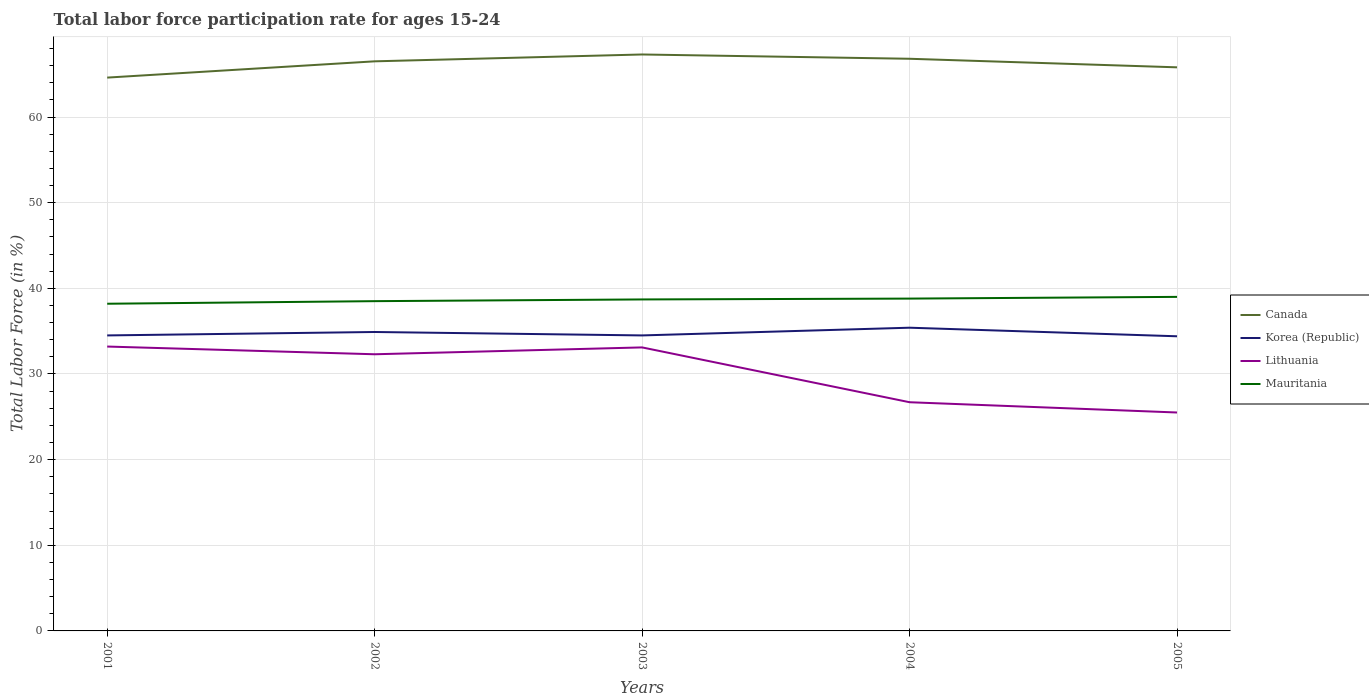How many different coloured lines are there?
Provide a short and direct response. 4. Does the line corresponding to Canada intersect with the line corresponding to Mauritania?
Make the answer very short. No. Across all years, what is the maximum labor force participation rate in Mauritania?
Keep it short and to the point. 38.2. What is the difference between the highest and the second highest labor force participation rate in Mauritania?
Provide a short and direct response. 0.8. Is the labor force participation rate in Lithuania strictly greater than the labor force participation rate in Korea (Republic) over the years?
Your answer should be compact. Yes. What is the difference between two consecutive major ticks on the Y-axis?
Provide a succinct answer. 10. Does the graph contain any zero values?
Give a very brief answer. No. Does the graph contain grids?
Your response must be concise. Yes. Where does the legend appear in the graph?
Provide a short and direct response. Center right. How many legend labels are there?
Your answer should be very brief. 4. What is the title of the graph?
Offer a very short reply. Total labor force participation rate for ages 15-24. Does "Timor-Leste" appear as one of the legend labels in the graph?
Provide a short and direct response. No. What is the Total Labor Force (in %) in Canada in 2001?
Your answer should be very brief. 64.6. What is the Total Labor Force (in %) in Korea (Republic) in 2001?
Make the answer very short. 34.5. What is the Total Labor Force (in %) of Lithuania in 2001?
Offer a terse response. 33.2. What is the Total Labor Force (in %) in Mauritania in 2001?
Ensure brevity in your answer.  38.2. What is the Total Labor Force (in %) of Canada in 2002?
Make the answer very short. 66.5. What is the Total Labor Force (in %) of Korea (Republic) in 2002?
Offer a very short reply. 34.9. What is the Total Labor Force (in %) of Lithuania in 2002?
Offer a very short reply. 32.3. What is the Total Labor Force (in %) of Mauritania in 2002?
Your answer should be compact. 38.5. What is the Total Labor Force (in %) in Canada in 2003?
Your response must be concise. 67.3. What is the Total Labor Force (in %) in Korea (Republic) in 2003?
Offer a terse response. 34.5. What is the Total Labor Force (in %) of Lithuania in 2003?
Your response must be concise. 33.1. What is the Total Labor Force (in %) in Mauritania in 2003?
Your answer should be very brief. 38.7. What is the Total Labor Force (in %) of Canada in 2004?
Your answer should be very brief. 66.8. What is the Total Labor Force (in %) of Korea (Republic) in 2004?
Offer a very short reply. 35.4. What is the Total Labor Force (in %) in Lithuania in 2004?
Offer a very short reply. 26.7. What is the Total Labor Force (in %) of Mauritania in 2004?
Give a very brief answer. 38.8. What is the Total Labor Force (in %) of Canada in 2005?
Provide a short and direct response. 65.8. What is the Total Labor Force (in %) of Korea (Republic) in 2005?
Offer a very short reply. 34.4. Across all years, what is the maximum Total Labor Force (in %) in Canada?
Make the answer very short. 67.3. Across all years, what is the maximum Total Labor Force (in %) of Korea (Republic)?
Give a very brief answer. 35.4. Across all years, what is the maximum Total Labor Force (in %) of Lithuania?
Your answer should be compact. 33.2. Across all years, what is the minimum Total Labor Force (in %) of Canada?
Make the answer very short. 64.6. Across all years, what is the minimum Total Labor Force (in %) of Korea (Republic)?
Your response must be concise. 34.4. Across all years, what is the minimum Total Labor Force (in %) of Lithuania?
Your response must be concise. 25.5. Across all years, what is the minimum Total Labor Force (in %) of Mauritania?
Your answer should be very brief. 38.2. What is the total Total Labor Force (in %) in Canada in the graph?
Give a very brief answer. 331. What is the total Total Labor Force (in %) in Korea (Republic) in the graph?
Give a very brief answer. 173.7. What is the total Total Labor Force (in %) in Lithuania in the graph?
Your response must be concise. 150.8. What is the total Total Labor Force (in %) of Mauritania in the graph?
Your answer should be very brief. 193.2. What is the difference between the Total Labor Force (in %) of Lithuania in 2001 and that in 2003?
Your response must be concise. 0.1. What is the difference between the Total Labor Force (in %) of Mauritania in 2001 and that in 2003?
Offer a terse response. -0.5. What is the difference between the Total Labor Force (in %) of Lithuania in 2001 and that in 2004?
Offer a very short reply. 6.5. What is the difference between the Total Labor Force (in %) of Canada in 2001 and that in 2005?
Give a very brief answer. -1.2. What is the difference between the Total Labor Force (in %) of Korea (Republic) in 2001 and that in 2005?
Provide a short and direct response. 0.1. What is the difference between the Total Labor Force (in %) of Lithuania in 2001 and that in 2005?
Your answer should be compact. 7.7. What is the difference between the Total Labor Force (in %) in Korea (Republic) in 2002 and that in 2003?
Give a very brief answer. 0.4. What is the difference between the Total Labor Force (in %) of Canada in 2002 and that in 2004?
Make the answer very short. -0.3. What is the difference between the Total Labor Force (in %) of Lithuania in 2002 and that in 2004?
Your answer should be compact. 5.6. What is the difference between the Total Labor Force (in %) in Mauritania in 2002 and that in 2004?
Provide a succinct answer. -0.3. What is the difference between the Total Labor Force (in %) in Mauritania in 2002 and that in 2005?
Offer a very short reply. -0.5. What is the difference between the Total Labor Force (in %) in Canada in 2003 and that in 2004?
Provide a short and direct response. 0.5. What is the difference between the Total Labor Force (in %) in Lithuania in 2003 and that in 2004?
Keep it short and to the point. 6.4. What is the difference between the Total Labor Force (in %) of Mauritania in 2003 and that in 2004?
Give a very brief answer. -0.1. What is the difference between the Total Labor Force (in %) of Canada in 2003 and that in 2005?
Keep it short and to the point. 1.5. What is the difference between the Total Labor Force (in %) in Korea (Republic) in 2003 and that in 2005?
Offer a terse response. 0.1. What is the difference between the Total Labor Force (in %) of Lithuania in 2003 and that in 2005?
Offer a very short reply. 7.6. What is the difference between the Total Labor Force (in %) of Mauritania in 2003 and that in 2005?
Offer a very short reply. -0.3. What is the difference between the Total Labor Force (in %) of Canada in 2004 and that in 2005?
Your response must be concise. 1. What is the difference between the Total Labor Force (in %) of Canada in 2001 and the Total Labor Force (in %) of Korea (Republic) in 2002?
Make the answer very short. 29.7. What is the difference between the Total Labor Force (in %) of Canada in 2001 and the Total Labor Force (in %) of Lithuania in 2002?
Your answer should be compact. 32.3. What is the difference between the Total Labor Force (in %) in Canada in 2001 and the Total Labor Force (in %) in Mauritania in 2002?
Offer a terse response. 26.1. What is the difference between the Total Labor Force (in %) in Korea (Republic) in 2001 and the Total Labor Force (in %) in Lithuania in 2002?
Offer a very short reply. 2.2. What is the difference between the Total Labor Force (in %) in Korea (Republic) in 2001 and the Total Labor Force (in %) in Mauritania in 2002?
Your answer should be very brief. -4. What is the difference between the Total Labor Force (in %) of Lithuania in 2001 and the Total Labor Force (in %) of Mauritania in 2002?
Provide a short and direct response. -5.3. What is the difference between the Total Labor Force (in %) in Canada in 2001 and the Total Labor Force (in %) in Korea (Republic) in 2003?
Offer a terse response. 30.1. What is the difference between the Total Labor Force (in %) in Canada in 2001 and the Total Labor Force (in %) in Lithuania in 2003?
Your answer should be compact. 31.5. What is the difference between the Total Labor Force (in %) in Canada in 2001 and the Total Labor Force (in %) in Mauritania in 2003?
Provide a succinct answer. 25.9. What is the difference between the Total Labor Force (in %) of Canada in 2001 and the Total Labor Force (in %) of Korea (Republic) in 2004?
Your answer should be compact. 29.2. What is the difference between the Total Labor Force (in %) of Canada in 2001 and the Total Labor Force (in %) of Lithuania in 2004?
Your answer should be very brief. 37.9. What is the difference between the Total Labor Force (in %) of Canada in 2001 and the Total Labor Force (in %) of Mauritania in 2004?
Offer a terse response. 25.8. What is the difference between the Total Labor Force (in %) in Korea (Republic) in 2001 and the Total Labor Force (in %) in Lithuania in 2004?
Your answer should be very brief. 7.8. What is the difference between the Total Labor Force (in %) of Lithuania in 2001 and the Total Labor Force (in %) of Mauritania in 2004?
Offer a very short reply. -5.6. What is the difference between the Total Labor Force (in %) of Canada in 2001 and the Total Labor Force (in %) of Korea (Republic) in 2005?
Ensure brevity in your answer.  30.2. What is the difference between the Total Labor Force (in %) of Canada in 2001 and the Total Labor Force (in %) of Lithuania in 2005?
Keep it short and to the point. 39.1. What is the difference between the Total Labor Force (in %) of Canada in 2001 and the Total Labor Force (in %) of Mauritania in 2005?
Your response must be concise. 25.6. What is the difference between the Total Labor Force (in %) of Korea (Republic) in 2001 and the Total Labor Force (in %) of Lithuania in 2005?
Make the answer very short. 9. What is the difference between the Total Labor Force (in %) in Korea (Republic) in 2001 and the Total Labor Force (in %) in Mauritania in 2005?
Keep it short and to the point. -4.5. What is the difference between the Total Labor Force (in %) in Canada in 2002 and the Total Labor Force (in %) in Korea (Republic) in 2003?
Keep it short and to the point. 32. What is the difference between the Total Labor Force (in %) of Canada in 2002 and the Total Labor Force (in %) of Lithuania in 2003?
Make the answer very short. 33.4. What is the difference between the Total Labor Force (in %) in Canada in 2002 and the Total Labor Force (in %) in Mauritania in 2003?
Make the answer very short. 27.8. What is the difference between the Total Labor Force (in %) in Korea (Republic) in 2002 and the Total Labor Force (in %) in Mauritania in 2003?
Ensure brevity in your answer.  -3.8. What is the difference between the Total Labor Force (in %) in Canada in 2002 and the Total Labor Force (in %) in Korea (Republic) in 2004?
Your answer should be compact. 31.1. What is the difference between the Total Labor Force (in %) of Canada in 2002 and the Total Labor Force (in %) of Lithuania in 2004?
Make the answer very short. 39.8. What is the difference between the Total Labor Force (in %) in Canada in 2002 and the Total Labor Force (in %) in Mauritania in 2004?
Your response must be concise. 27.7. What is the difference between the Total Labor Force (in %) of Korea (Republic) in 2002 and the Total Labor Force (in %) of Lithuania in 2004?
Provide a short and direct response. 8.2. What is the difference between the Total Labor Force (in %) of Korea (Republic) in 2002 and the Total Labor Force (in %) of Mauritania in 2004?
Provide a short and direct response. -3.9. What is the difference between the Total Labor Force (in %) of Lithuania in 2002 and the Total Labor Force (in %) of Mauritania in 2004?
Ensure brevity in your answer.  -6.5. What is the difference between the Total Labor Force (in %) in Canada in 2002 and the Total Labor Force (in %) in Korea (Republic) in 2005?
Provide a succinct answer. 32.1. What is the difference between the Total Labor Force (in %) of Canada in 2003 and the Total Labor Force (in %) of Korea (Republic) in 2004?
Offer a terse response. 31.9. What is the difference between the Total Labor Force (in %) of Canada in 2003 and the Total Labor Force (in %) of Lithuania in 2004?
Make the answer very short. 40.6. What is the difference between the Total Labor Force (in %) of Korea (Republic) in 2003 and the Total Labor Force (in %) of Lithuania in 2004?
Provide a short and direct response. 7.8. What is the difference between the Total Labor Force (in %) of Lithuania in 2003 and the Total Labor Force (in %) of Mauritania in 2004?
Offer a terse response. -5.7. What is the difference between the Total Labor Force (in %) in Canada in 2003 and the Total Labor Force (in %) in Korea (Republic) in 2005?
Offer a terse response. 32.9. What is the difference between the Total Labor Force (in %) of Canada in 2003 and the Total Labor Force (in %) of Lithuania in 2005?
Ensure brevity in your answer.  41.8. What is the difference between the Total Labor Force (in %) of Canada in 2003 and the Total Labor Force (in %) of Mauritania in 2005?
Your answer should be very brief. 28.3. What is the difference between the Total Labor Force (in %) of Canada in 2004 and the Total Labor Force (in %) of Korea (Republic) in 2005?
Provide a short and direct response. 32.4. What is the difference between the Total Labor Force (in %) in Canada in 2004 and the Total Labor Force (in %) in Lithuania in 2005?
Ensure brevity in your answer.  41.3. What is the difference between the Total Labor Force (in %) of Canada in 2004 and the Total Labor Force (in %) of Mauritania in 2005?
Keep it short and to the point. 27.8. What is the average Total Labor Force (in %) of Canada per year?
Your answer should be very brief. 66.2. What is the average Total Labor Force (in %) in Korea (Republic) per year?
Ensure brevity in your answer.  34.74. What is the average Total Labor Force (in %) in Lithuania per year?
Provide a succinct answer. 30.16. What is the average Total Labor Force (in %) of Mauritania per year?
Provide a short and direct response. 38.64. In the year 2001, what is the difference between the Total Labor Force (in %) in Canada and Total Labor Force (in %) in Korea (Republic)?
Your response must be concise. 30.1. In the year 2001, what is the difference between the Total Labor Force (in %) of Canada and Total Labor Force (in %) of Lithuania?
Offer a very short reply. 31.4. In the year 2001, what is the difference between the Total Labor Force (in %) in Canada and Total Labor Force (in %) in Mauritania?
Offer a very short reply. 26.4. In the year 2001, what is the difference between the Total Labor Force (in %) in Korea (Republic) and Total Labor Force (in %) in Lithuania?
Give a very brief answer. 1.3. In the year 2002, what is the difference between the Total Labor Force (in %) of Canada and Total Labor Force (in %) of Korea (Republic)?
Give a very brief answer. 31.6. In the year 2002, what is the difference between the Total Labor Force (in %) in Canada and Total Labor Force (in %) in Lithuania?
Provide a short and direct response. 34.2. In the year 2002, what is the difference between the Total Labor Force (in %) in Canada and Total Labor Force (in %) in Mauritania?
Keep it short and to the point. 28. In the year 2002, what is the difference between the Total Labor Force (in %) in Korea (Republic) and Total Labor Force (in %) in Lithuania?
Offer a very short reply. 2.6. In the year 2003, what is the difference between the Total Labor Force (in %) of Canada and Total Labor Force (in %) of Korea (Republic)?
Make the answer very short. 32.8. In the year 2003, what is the difference between the Total Labor Force (in %) of Canada and Total Labor Force (in %) of Lithuania?
Give a very brief answer. 34.2. In the year 2003, what is the difference between the Total Labor Force (in %) of Canada and Total Labor Force (in %) of Mauritania?
Provide a succinct answer. 28.6. In the year 2003, what is the difference between the Total Labor Force (in %) in Korea (Republic) and Total Labor Force (in %) in Lithuania?
Offer a terse response. 1.4. In the year 2003, what is the difference between the Total Labor Force (in %) in Korea (Republic) and Total Labor Force (in %) in Mauritania?
Your answer should be very brief. -4.2. In the year 2004, what is the difference between the Total Labor Force (in %) in Canada and Total Labor Force (in %) in Korea (Republic)?
Provide a short and direct response. 31.4. In the year 2004, what is the difference between the Total Labor Force (in %) of Canada and Total Labor Force (in %) of Lithuania?
Offer a very short reply. 40.1. In the year 2004, what is the difference between the Total Labor Force (in %) in Lithuania and Total Labor Force (in %) in Mauritania?
Make the answer very short. -12.1. In the year 2005, what is the difference between the Total Labor Force (in %) in Canada and Total Labor Force (in %) in Korea (Republic)?
Offer a very short reply. 31.4. In the year 2005, what is the difference between the Total Labor Force (in %) of Canada and Total Labor Force (in %) of Lithuania?
Your response must be concise. 40.3. In the year 2005, what is the difference between the Total Labor Force (in %) in Canada and Total Labor Force (in %) in Mauritania?
Provide a succinct answer. 26.8. In the year 2005, what is the difference between the Total Labor Force (in %) of Korea (Republic) and Total Labor Force (in %) of Mauritania?
Offer a very short reply. -4.6. In the year 2005, what is the difference between the Total Labor Force (in %) of Lithuania and Total Labor Force (in %) of Mauritania?
Provide a short and direct response. -13.5. What is the ratio of the Total Labor Force (in %) of Canada in 2001 to that in 2002?
Keep it short and to the point. 0.97. What is the ratio of the Total Labor Force (in %) of Lithuania in 2001 to that in 2002?
Offer a very short reply. 1.03. What is the ratio of the Total Labor Force (in %) in Canada in 2001 to that in 2003?
Offer a very short reply. 0.96. What is the ratio of the Total Labor Force (in %) in Mauritania in 2001 to that in 2003?
Make the answer very short. 0.99. What is the ratio of the Total Labor Force (in %) of Canada in 2001 to that in 2004?
Your response must be concise. 0.97. What is the ratio of the Total Labor Force (in %) of Korea (Republic) in 2001 to that in 2004?
Give a very brief answer. 0.97. What is the ratio of the Total Labor Force (in %) of Lithuania in 2001 to that in 2004?
Provide a short and direct response. 1.24. What is the ratio of the Total Labor Force (in %) in Mauritania in 2001 to that in 2004?
Give a very brief answer. 0.98. What is the ratio of the Total Labor Force (in %) in Canada in 2001 to that in 2005?
Keep it short and to the point. 0.98. What is the ratio of the Total Labor Force (in %) of Lithuania in 2001 to that in 2005?
Provide a succinct answer. 1.3. What is the ratio of the Total Labor Force (in %) of Mauritania in 2001 to that in 2005?
Your response must be concise. 0.98. What is the ratio of the Total Labor Force (in %) in Canada in 2002 to that in 2003?
Keep it short and to the point. 0.99. What is the ratio of the Total Labor Force (in %) in Korea (Republic) in 2002 to that in 2003?
Offer a terse response. 1.01. What is the ratio of the Total Labor Force (in %) of Lithuania in 2002 to that in 2003?
Provide a short and direct response. 0.98. What is the ratio of the Total Labor Force (in %) in Canada in 2002 to that in 2004?
Your answer should be very brief. 1. What is the ratio of the Total Labor Force (in %) of Korea (Republic) in 2002 to that in 2004?
Offer a very short reply. 0.99. What is the ratio of the Total Labor Force (in %) in Lithuania in 2002 to that in 2004?
Your answer should be compact. 1.21. What is the ratio of the Total Labor Force (in %) in Mauritania in 2002 to that in 2004?
Offer a very short reply. 0.99. What is the ratio of the Total Labor Force (in %) in Canada in 2002 to that in 2005?
Give a very brief answer. 1.01. What is the ratio of the Total Labor Force (in %) in Korea (Republic) in 2002 to that in 2005?
Give a very brief answer. 1.01. What is the ratio of the Total Labor Force (in %) in Lithuania in 2002 to that in 2005?
Keep it short and to the point. 1.27. What is the ratio of the Total Labor Force (in %) in Mauritania in 2002 to that in 2005?
Your response must be concise. 0.99. What is the ratio of the Total Labor Force (in %) in Canada in 2003 to that in 2004?
Provide a short and direct response. 1.01. What is the ratio of the Total Labor Force (in %) of Korea (Republic) in 2003 to that in 2004?
Provide a succinct answer. 0.97. What is the ratio of the Total Labor Force (in %) of Lithuania in 2003 to that in 2004?
Your answer should be compact. 1.24. What is the ratio of the Total Labor Force (in %) in Mauritania in 2003 to that in 2004?
Ensure brevity in your answer.  1. What is the ratio of the Total Labor Force (in %) in Canada in 2003 to that in 2005?
Your answer should be compact. 1.02. What is the ratio of the Total Labor Force (in %) of Lithuania in 2003 to that in 2005?
Provide a short and direct response. 1.3. What is the ratio of the Total Labor Force (in %) of Mauritania in 2003 to that in 2005?
Ensure brevity in your answer.  0.99. What is the ratio of the Total Labor Force (in %) in Canada in 2004 to that in 2005?
Ensure brevity in your answer.  1.02. What is the ratio of the Total Labor Force (in %) in Korea (Republic) in 2004 to that in 2005?
Your answer should be very brief. 1.03. What is the ratio of the Total Labor Force (in %) of Lithuania in 2004 to that in 2005?
Keep it short and to the point. 1.05. What is the difference between the highest and the second highest Total Labor Force (in %) of Canada?
Provide a short and direct response. 0.5. What is the difference between the highest and the second highest Total Labor Force (in %) of Korea (Republic)?
Keep it short and to the point. 0.5. What is the difference between the highest and the second highest Total Labor Force (in %) of Lithuania?
Make the answer very short. 0.1. What is the difference between the highest and the lowest Total Labor Force (in %) in Korea (Republic)?
Give a very brief answer. 1. What is the difference between the highest and the lowest Total Labor Force (in %) in Mauritania?
Keep it short and to the point. 0.8. 